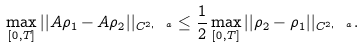Convert formula to latex. <formula><loc_0><loc_0><loc_500><loc_500>\max _ { [ 0 , T ] } | | A \rho _ { 1 } - A \rho _ { 2 } | | _ { C ^ { 2 , \ a } } \leq \frac { 1 } { 2 } \max _ { [ 0 , T ] } | | \rho _ { 2 } - \rho _ { 1 } | | _ { C ^ { 2 , \ a } } .</formula> 